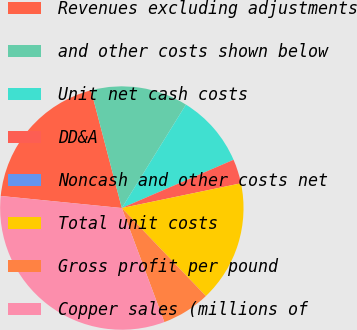<chart> <loc_0><loc_0><loc_500><loc_500><pie_chart><fcel>Revenues excluding adjustments<fcel>and other costs shown below<fcel>Unit net cash costs<fcel>DD&A<fcel>Noncash and other costs net<fcel>Total unit costs<fcel>Gross profit per pound<fcel>Copper sales (millions of<nl><fcel>19.35%<fcel>12.9%<fcel>9.68%<fcel>3.23%<fcel>0.0%<fcel>16.13%<fcel>6.45%<fcel>32.26%<nl></chart> 